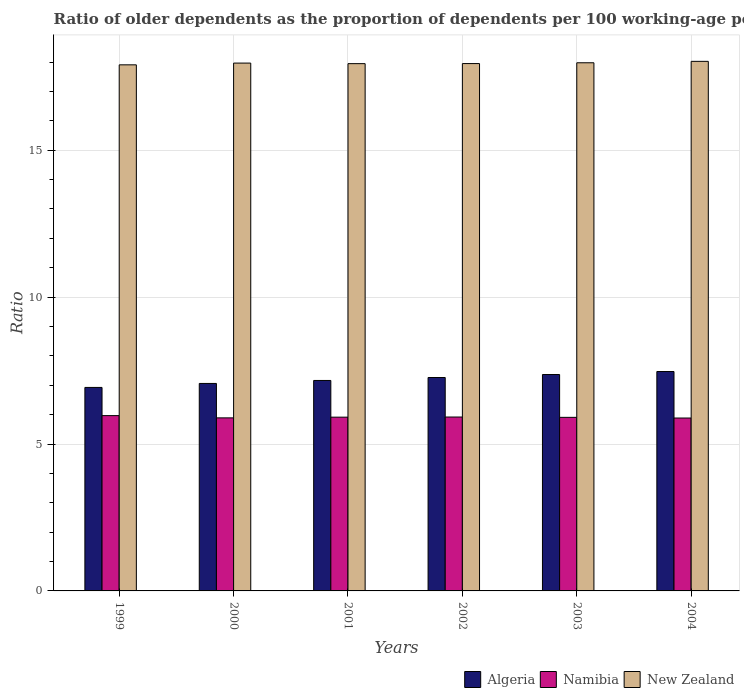Are the number of bars on each tick of the X-axis equal?
Give a very brief answer. Yes. How many bars are there on the 2nd tick from the left?
Your response must be concise. 3. How many bars are there on the 3rd tick from the right?
Offer a very short reply. 3. What is the age dependency ratio(old) in New Zealand in 2004?
Offer a terse response. 18.02. Across all years, what is the maximum age dependency ratio(old) in Namibia?
Keep it short and to the point. 5.97. Across all years, what is the minimum age dependency ratio(old) in Algeria?
Offer a very short reply. 6.93. What is the total age dependency ratio(old) in Namibia in the graph?
Your response must be concise. 35.48. What is the difference between the age dependency ratio(old) in New Zealand in 2002 and that in 2003?
Provide a short and direct response. -0.03. What is the difference between the age dependency ratio(old) in New Zealand in 2000 and the age dependency ratio(old) in Namibia in 1999?
Keep it short and to the point. 12. What is the average age dependency ratio(old) in Algeria per year?
Your response must be concise. 7.21. In the year 2001, what is the difference between the age dependency ratio(old) in Namibia and age dependency ratio(old) in Algeria?
Your response must be concise. -1.25. In how many years, is the age dependency ratio(old) in Algeria greater than 8?
Keep it short and to the point. 0. What is the ratio of the age dependency ratio(old) in Namibia in 2001 to that in 2004?
Ensure brevity in your answer.  1. Is the difference between the age dependency ratio(old) in Namibia in 2000 and 2004 greater than the difference between the age dependency ratio(old) in Algeria in 2000 and 2004?
Give a very brief answer. Yes. What is the difference between the highest and the second highest age dependency ratio(old) in Algeria?
Ensure brevity in your answer.  0.1. What is the difference between the highest and the lowest age dependency ratio(old) in Algeria?
Ensure brevity in your answer.  0.54. In how many years, is the age dependency ratio(old) in Namibia greater than the average age dependency ratio(old) in Namibia taken over all years?
Provide a short and direct response. 3. What does the 1st bar from the left in 2001 represents?
Your response must be concise. Algeria. What does the 3rd bar from the right in 2000 represents?
Your answer should be very brief. Algeria. Are the values on the major ticks of Y-axis written in scientific E-notation?
Make the answer very short. No. Does the graph contain any zero values?
Offer a terse response. No. Where does the legend appear in the graph?
Your response must be concise. Bottom right. How many legend labels are there?
Ensure brevity in your answer.  3. How are the legend labels stacked?
Provide a succinct answer. Horizontal. What is the title of the graph?
Your answer should be compact. Ratio of older dependents as the proportion of dependents per 100 working-age population. What is the label or title of the Y-axis?
Provide a short and direct response. Ratio. What is the Ratio in Algeria in 1999?
Provide a succinct answer. 6.93. What is the Ratio in Namibia in 1999?
Make the answer very short. 5.97. What is the Ratio of New Zealand in 1999?
Provide a succinct answer. 17.9. What is the Ratio in Algeria in 2000?
Offer a terse response. 7.06. What is the Ratio in Namibia in 2000?
Your response must be concise. 5.89. What is the Ratio of New Zealand in 2000?
Keep it short and to the point. 17.96. What is the Ratio of Algeria in 2001?
Your response must be concise. 7.16. What is the Ratio in Namibia in 2001?
Offer a very short reply. 5.91. What is the Ratio of New Zealand in 2001?
Keep it short and to the point. 17.94. What is the Ratio of Algeria in 2002?
Your answer should be very brief. 7.26. What is the Ratio of Namibia in 2002?
Offer a very short reply. 5.92. What is the Ratio in New Zealand in 2002?
Provide a succinct answer. 17.95. What is the Ratio of Algeria in 2003?
Provide a short and direct response. 7.36. What is the Ratio of Namibia in 2003?
Your answer should be compact. 5.91. What is the Ratio of New Zealand in 2003?
Make the answer very short. 17.97. What is the Ratio of Algeria in 2004?
Ensure brevity in your answer.  7.47. What is the Ratio in Namibia in 2004?
Give a very brief answer. 5.88. What is the Ratio of New Zealand in 2004?
Provide a short and direct response. 18.02. Across all years, what is the maximum Ratio of Algeria?
Provide a succinct answer. 7.47. Across all years, what is the maximum Ratio in Namibia?
Keep it short and to the point. 5.97. Across all years, what is the maximum Ratio in New Zealand?
Ensure brevity in your answer.  18.02. Across all years, what is the minimum Ratio of Algeria?
Give a very brief answer. 6.93. Across all years, what is the minimum Ratio in Namibia?
Your response must be concise. 5.88. Across all years, what is the minimum Ratio of New Zealand?
Provide a succinct answer. 17.9. What is the total Ratio of Algeria in the graph?
Keep it short and to the point. 43.24. What is the total Ratio of Namibia in the graph?
Make the answer very short. 35.48. What is the total Ratio of New Zealand in the graph?
Ensure brevity in your answer.  107.76. What is the difference between the Ratio of Algeria in 1999 and that in 2000?
Your answer should be very brief. -0.14. What is the difference between the Ratio in Namibia in 1999 and that in 2000?
Your response must be concise. 0.08. What is the difference between the Ratio of New Zealand in 1999 and that in 2000?
Give a very brief answer. -0.06. What is the difference between the Ratio of Algeria in 1999 and that in 2001?
Provide a short and direct response. -0.24. What is the difference between the Ratio in Namibia in 1999 and that in 2001?
Provide a succinct answer. 0.05. What is the difference between the Ratio in New Zealand in 1999 and that in 2001?
Your answer should be very brief. -0.04. What is the difference between the Ratio of Algeria in 1999 and that in 2002?
Your answer should be compact. -0.34. What is the difference between the Ratio of Namibia in 1999 and that in 2002?
Make the answer very short. 0.05. What is the difference between the Ratio in New Zealand in 1999 and that in 2002?
Provide a short and direct response. -0.04. What is the difference between the Ratio in Algeria in 1999 and that in 2003?
Offer a terse response. -0.44. What is the difference between the Ratio in Namibia in 1999 and that in 2003?
Your answer should be very brief. 0.06. What is the difference between the Ratio in New Zealand in 1999 and that in 2003?
Give a very brief answer. -0.07. What is the difference between the Ratio of Algeria in 1999 and that in 2004?
Provide a succinct answer. -0.54. What is the difference between the Ratio of Namibia in 1999 and that in 2004?
Offer a terse response. 0.08. What is the difference between the Ratio of New Zealand in 1999 and that in 2004?
Your answer should be compact. -0.12. What is the difference between the Ratio of Algeria in 2000 and that in 2001?
Provide a succinct answer. -0.1. What is the difference between the Ratio of Namibia in 2000 and that in 2001?
Your answer should be compact. -0.02. What is the difference between the Ratio of New Zealand in 2000 and that in 2001?
Your answer should be compact. 0.02. What is the difference between the Ratio in Algeria in 2000 and that in 2002?
Make the answer very short. -0.2. What is the difference between the Ratio in Namibia in 2000 and that in 2002?
Make the answer very short. -0.03. What is the difference between the Ratio in New Zealand in 2000 and that in 2002?
Make the answer very short. 0.02. What is the difference between the Ratio in Algeria in 2000 and that in 2003?
Give a very brief answer. -0.3. What is the difference between the Ratio in Namibia in 2000 and that in 2003?
Provide a succinct answer. -0.02. What is the difference between the Ratio in New Zealand in 2000 and that in 2003?
Keep it short and to the point. -0.01. What is the difference between the Ratio of Algeria in 2000 and that in 2004?
Make the answer very short. -0.41. What is the difference between the Ratio in Namibia in 2000 and that in 2004?
Give a very brief answer. 0.01. What is the difference between the Ratio of New Zealand in 2000 and that in 2004?
Ensure brevity in your answer.  -0.06. What is the difference between the Ratio of Algeria in 2001 and that in 2002?
Provide a succinct answer. -0.1. What is the difference between the Ratio of Namibia in 2001 and that in 2002?
Your answer should be very brief. -0. What is the difference between the Ratio in New Zealand in 2001 and that in 2002?
Make the answer very short. -0. What is the difference between the Ratio of Algeria in 2001 and that in 2003?
Provide a succinct answer. -0.2. What is the difference between the Ratio of Namibia in 2001 and that in 2003?
Provide a succinct answer. 0.01. What is the difference between the Ratio of New Zealand in 2001 and that in 2003?
Offer a terse response. -0.03. What is the difference between the Ratio of Algeria in 2001 and that in 2004?
Your response must be concise. -0.3. What is the difference between the Ratio in Namibia in 2001 and that in 2004?
Offer a very short reply. 0.03. What is the difference between the Ratio in New Zealand in 2001 and that in 2004?
Your answer should be compact. -0.08. What is the difference between the Ratio of Algeria in 2002 and that in 2003?
Keep it short and to the point. -0.1. What is the difference between the Ratio of Namibia in 2002 and that in 2003?
Your response must be concise. 0.01. What is the difference between the Ratio of New Zealand in 2002 and that in 2003?
Provide a short and direct response. -0.03. What is the difference between the Ratio in Algeria in 2002 and that in 2004?
Your answer should be very brief. -0.2. What is the difference between the Ratio in Namibia in 2002 and that in 2004?
Offer a terse response. 0.03. What is the difference between the Ratio of New Zealand in 2002 and that in 2004?
Keep it short and to the point. -0.08. What is the difference between the Ratio in Algeria in 2003 and that in 2004?
Your response must be concise. -0.1. What is the difference between the Ratio of Namibia in 2003 and that in 2004?
Make the answer very short. 0.02. What is the difference between the Ratio of New Zealand in 2003 and that in 2004?
Your answer should be compact. -0.05. What is the difference between the Ratio of Algeria in 1999 and the Ratio of Namibia in 2000?
Provide a succinct answer. 1.04. What is the difference between the Ratio in Algeria in 1999 and the Ratio in New Zealand in 2000?
Offer a very short reply. -11.04. What is the difference between the Ratio in Namibia in 1999 and the Ratio in New Zealand in 2000?
Ensure brevity in your answer.  -12. What is the difference between the Ratio in Algeria in 1999 and the Ratio in Namibia in 2001?
Make the answer very short. 1.01. What is the difference between the Ratio of Algeria in 1999 and the Ratio of New Zealand in 2001?
Offer a very short reply. -11.02. What is the difference between the Ratio in Namibia in 1999 and the Ratio in New Zealand in 2001?
Keep it short and to the point. -11.98. What is the difference between the Ratio of Algeria in 1999 and the Ratio of Namibia in 2002?
Offer a terse response. 1.01. What is the difference between the Ratio of Algeria in 1999 and the Ratio of New Zealand in 2002?
Offer a terse response. -11.02. What is the difference between the Ratio in Namibia in 1999 and the Ratio in New Zealand in 2002?
Make the answer very short. -11.98. What is the difference between the Ratio in Algeria in 1999 and the Ratio in Namibia in 2003?
Make the answer very short. 1.02. What is the difference between the Ratio in Algeria in 1999 and the Ratio in New Zealand in 2003?
Give a very brief answer. -11.05. What is the difference between the Ratio in Namibia in 1999 and the Ratio in New Zealand in 2003?
Offer a terse response. -12.01. What is the difference between the Ratio in Algeria in 1999 and the Ratio in Namibia in 2004?
Ensure brevity in your answer.  1.04. What is the difference between the Ratio in Algeria in 1999 and the Ratio in New Zealand in 2004?
Keep it short and to the point. -11.1. What is the difference between the Ratio in Namibia in 1999 and the Ratio in New Zealand in 2004?
Your response must be concise. -12.06. What is the difference between the Ratio in Algeria in 2000 and the Ratio in Namibia in 2001?
Your answer should be very brief. 1.15. What is the difference between the Ratio of Algeria in 2000 and the Ratio of New Zealand in 2001?
Provide a short and direct response. -10.88. What is the difference between the Ratio of Namibia in 2000 and the Ratio of New Zealand in 2001?
Give a very brief answer. -12.05. What is the difference between the Ratio in Algeria in 2000 and the Ratio in Namibia in 2002?
Ensure brevity in your answer.  1.14. What is the difference between the Ratio in Algeria in 2000 and the Ratio in New Zealand in 2002?
Your response must be concise. -10.89. What is the difference between the Ratio in Namibia in 2000 and the Ratio in New Zealand in 2002?
Keep it short and to the point. -12.06. What is the difference between the Ratio of Algeria in 2000 and the Ratio of Namibia in 2003?
Make the answer very short. 1.15. What is the difference between the Ratio of Algeria in 2000 and the Ratio of New Zealand in 2003?
Offer a terse response. -10.91. What is the difference between the Ratio in Namibia in 2000 and the Ratio in New Zealand in 2003?
Offer a terse response. -12.09. What is the difference between the Ratio in Algeria in 2000 and the Ratio in Namibia in 2004?
Give a very brief answer. 1.18. What is the difference between the Ratio of Algeria in 2000 and the Ratio of New Zealand in 2004?
Offer a terse response. -10.96. What is the difference between the Ratio in Namibia in 2000 and the Ratio in New Zealand in 2004?
Ensure brevity in your answer.  -12.13. What is the difference between the Ratio in Algeria in 2001 and the Ratio in Namibia in 2002?
Provide a short and direct response. 1.24. What is the difference between the Ratio of Algeria in 2001 and the Ratio of New Zealand in 2002?
Offer a terse response. -10.78. What is the difference between the Ratio of Namibia in 2001 and the Ratio of New Zealand in 2002?
Make the answer very short. -12.03. What is the difference between the Ratio of Algeria in 2001 and the Ratio of Namibia in 2003?
Your answer should be very brief. 1.26. What is the difference between the Ratio of Algeria in 2001 and the Ratio of New Zealand in 2003?
Provide a succinct answer. -10.81. What is the difference between the Ratio in Namibia in 2001 and the Ratio in New Zealand in 2003?
Keep it short and to the point. -12.06. What is the difference between the Ratio in Algeria in 2001 and the Ratio in Namibia in 2004?
Keep it short and to the point. 1.28. What is the difference between the Ratio in Algeria in 2001 and the Ratio in New Zealand in 2004?
Provide a short and direct response. -10.86. What is the difference between the Ratio in Namibia in 2001 and the Ratio in New Zealand in 2004?
Provide a succinct answer. -12.11. What is the difference between the Ratio of Algeria in 2002 and the Ratio of Namibia in 2003?
Provide a succinct answer. 1.36. What is the difference between the Ratio in Algeria in 2002 and the Ratio in New Zealand in 2003?
Your answer should be very brief. -10.71. What is the difference between the Ratio in Namibia in 2002 and the Ratio in New Zealand in 2003?
Your answer should be compact. -12.06. What is the difference between the Ratio in Algeria in 2002 and the Ratio in Namibia in 2004?
Provide a succinct answer. 1.38. What is the difference between the Ratio in Algeria in 2002 and the Ratio in New Zealand in 2004?
Keep it short and to the point. -10.76. What is the difference between the Ratio of Namibia in 2002 and the Ratio of New Zealand in 2004?
Keep it short and to the point. -12.1. What is the difference between the Ratio in Algeria in 2003 and the Ratio in Namibia in 2004?
Provide a succinct answer. 1.48. What is the difference between the Ratio of Algeria in 2003 and the Ratio of New Zealand in 2004?
Provide a short and direct response. -10.66. What is the difference between the Ratio in Namibia in 2003 and the Ratio in New Zealand in 2004?
Provide a succinct answer. -12.12. What is the average Ratio in Algeria per year?
Offer a very short reply. 7.21. What is the average Ratio in Namibia per year?
Ensure brevity in your answer.  5.91. What is the average Ratio in New Zealand per year?
Your answer should be compact. 17.96. In the year 1999, what is the difference between the Ratio in Algeria and Ratio in Namibia?
Make the answer very short. 0.96. In the year 1999, what is the difference between the Ratio in Algeria and Ratio in New Zealand?
Ensure brevity in your answer.  -10.98. In the year 1999, what is the difference between the Ratio in Namibia and Ratio in New Zealand?
Give a very brief answer. -11.94. In the year 2000, what is the difference between the Ratio of Algeria and Ratio of Namibia?
Your response must be concise. 1.17. In the year 2000, what is the difference between the Ratio of Algeria and Ratio of New Zealand?
Provide a short and direct response. -10.9. In the year 2000, what is the difference between the Ratio in Namibia and Ratio in New Zealand?
Give a very brief answer. -12.07. In the year 2001, what is the difference between the Ratio of Algeria and Ratio of Namibia?
Provide a short and direct response. 1.25. In the year 2001, what is the difference between the Ratio of Algeria and Ratio of New Zealand?
Offer a very short reply. -10.78. In the year 2001, what is the difference between the Ratio of Namibia and Ratio of New Zealand?
Make the answer very short. -12.03. In the year 2002, what is the difference between the Ratio in Algeria and Ratio in Namibia?
Keep it short and to the point. 1.34. In the year 2002, what is the difference between the Ratio in Algeria and Ratio in New Zealand?
Provide a succinct answer. -10.68. In the year 2002, what is the difference between the Ratio of Namibia and Ratio of New Zealand?
Your answer should be compact. -12.03. In the year 2003, what is the difference between the Ratio of Algeria and Ratio of Namibia?
Keep it short and to the point. 1.46. In the year 2003, what is the difference between the Ratio in Algeria and Ratio in New Zealand?
Make the answer very short. -10.61. In the year 2003, what is the difference between the Ratio in Namibia and Ratio in New Zealand?
Provide a short and direct response. -12.07. In the year 2004, what is the difference between the Ratio of Algeria and Ratio of Namibia?
Keep it short and to the point. 1.58. In the year 2004, what is the difference between the Ratio in Algeria and Ratio in New Zealand?
Ensure brevity in your answer.  -10.56. In the year 2004, what is the difference between the Ratio in Namibia and Ratio in New Zealand?
Ensure brevity in your answer.  -12.14. What is the ratio of the Ratio of Algeria in 1999 to that in 2000?
Ensure brevity in your answer.  0.98. What is the ratio of the Ratio in Namibia in 1999 to that in 2000?
Keep it short and to the point. 1.01. What is the ratio of the Ratio in New Zealand in 1999 to that in 2000?
Your answer should be very brief. 1. What is the ratio of the Ratio in Algeria in 1999 to that in 2001?
Give a very brief answer. 0.97. What is the ratio of the Ratio in New Zealand in 1999 to that in 2001?
Make the answer very short. 1. What is the ratio of the Ratio in Algeria in 1999 to that in 2002?
Give a very brief answer. 0.95. What is the ratio of the Ratio of Namibia in 1999 to that in 2002?
Your answer should be compact. 1.01. What is the ratio of the Ratio of New Zealand in 1999 to that in 2002?
Keep it short and to the point. 1. What is the ratio of the Ratio of Algeria in 1999 to that in 2003?
Provide a succinct answer. 0.94. What is the ratio of the Ratio in Algeria in 1999 to that in 2004?
Ensure brevity in your answer.  0.93. What is the ratio of the Ratio of Namibia in 1999 to that in 2004?
Give a very brief answer. 1.01. What is the ratio of the Ratio of Algeria in 2000 to that in 2001?
Make the answer very short. 0.99. What is the ratio of the Ratio in Namibia in 2000 to that in 2001?
Your response must be concise. 1. What is the ratio of the Ratio of Algeria in 2000 to that in 2002?
Your response must be concise. 0.97. What is the ratio of the Ratio in Namibia in 2000 to that in 2002?
Give a very brief answer. 1. What is the ratio of the Ratio of New Zealand in 2000 to that in 2002?
Ensure brevity in your answer.  1. What is the ratio of the Ratio of Algeria in 2000 to that in 2003?
Provide a succinct answer. 0.96. What is the ratio of the Ratio of New Zealand in 2000 to that in 2003?
Ensure brevity in your answer.  1. What is the ratio of the Ratio of Algeria in 2000 to that in 2004?
Ensure brevity in your answer.  0.95. What is the ratio of the Ratio of Algeria in 2001 to that in 2002?
Ensure brevity in your answer.  0.99. What is the ratio of the Ratio in Namibia in 2001 to that in 2002?
Your response must be concise. 1. What is the ratio of the Ratio of New Zealand in 2001 to that in 2002?
Keep it short and to the point. 1. What is the ratio of the Ratio of Algeria in 2001 to that in 2003?
Your response must be concise. 0.97. What is the ratio of the Ratio of New Zealand in 2001 to that in 2003?
Make the answer very short. 1. What is the ratio of the Ratio of Algeria in 2001 to that in 2004?
Give a very brief answer. 0.96. What is the ratio of the Ratio of Namibia in 2001 to that in 2004?
Your response must be concise. 1. What is the ratio of the Ratio of New Zealand in 2001 to that in 2004?
Offer a terse response. 1. What is the ratio of the Ratio in Algeria in 2002 to that in 2003?
Your answer should be very brief. 0.99. What is the ratio of the Ratio of New Zealand in 2002 to that in 2003?
Ensure brevity in your answer.  1. What is the ratio of the Ratio in Algeria in 2002 to that in 2004?
Make the answer very short. 0.97. What is the ratio of the Ratio of Namibia in 2002 to that in 2004?
Offer a terse response. 1.01. What is the ratio of the Ratio in Algeria in 2003 to that in 2004?
Keep it short and to the point. 0.99. What is the ratio of the Ratio of Namibia in 2003 to that in 2004?
Your answer should be compact. 1. What is the ratio of the Ratio in New Zealand in 2003 to that in 2004?
Give a very brief answer. 1. What is the difference between the highest and the second highest Ratio in Algeria?
Keep it short and to the point. 0.1. What is the difference between the highest and the second highest Ratio in Namibia?
Provide a short and direct response. 0.05. What is the difference between the highest and the second highest Ratio of New Zealand?
Make the answer very short. 0.05. What is the difference between the highest and the lowest Ratio in Algeria?
Give a very brief answer. 0.54. What is the difference between the highest and the lowest Ratio of Namibia?
Your response must be concise. 0.08. What is the difference between the highest and the lowest Ratio in New Zealand?
Your answer should be compact. 0.12. 